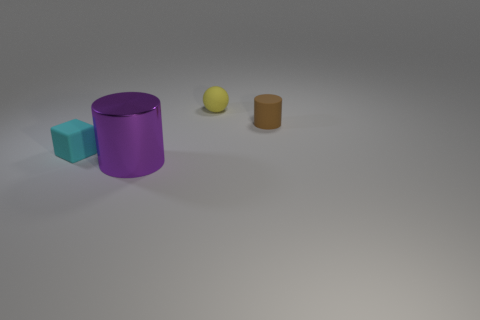What is the material of the purple thing?
Your answer should be compact. Metal. There is a cyan matte cube; how many things are behind it?
Provide a short and direct response. 2. Is the big object the same color as the small ball?
Make the answer very short. No. What number of rubber blocks are the same color as the ball?
Your response must be concise. 0. Are there more big yellow cylinders than shiny cylinders?
Make the answer very short. No. What size is the object that is behind the purple metal cylinder and to the left of the tiny yellow ball?
Offer a very short reply. Small. Are the thing that is to the left of the big purple shiny thing and the cylinder that is behind the small cube made of the same material?
Your answer should be very brief. Yes. What is the shape of the cyan object that is the same size as the yellow sphere?
Offer a terse response. Cube. Is the number of blue cubes less than the number of rubber cylinders?
Provide a short and direct response. Yes. Is there a matte thing in front of the thing on the right side of the yellow thing?
Ensure brevity in your answer.  Yes. 